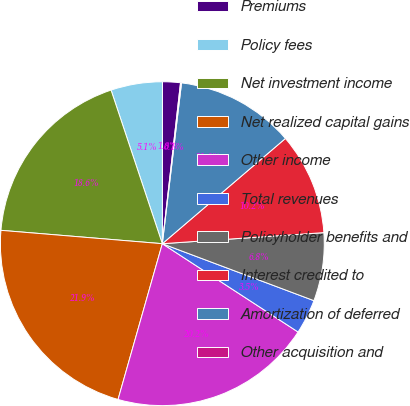Convert chart. <chart><loc_0><loc_0><loc_500><loc_500><pie_chart><fcel>Premiums<fcel>Policy fees<fcel>Net investment income<fcel>Net realized capital gains<fcel>Other income<fcel>Total revenues<fcel>Policyholder benefits and<fcel>Interest credited to<fcel>Amortization of deferred<fcel>Other acquisition and<nl><fcel>1.78%<fcel>5.14%<fcel>18.56%<fcel>21.91%<fcel>20.23%<fcel>3.46%<fcel>6.81%<fcel>10.17%<fcel>11.85%<fcel>0.1%<nl></chart> 